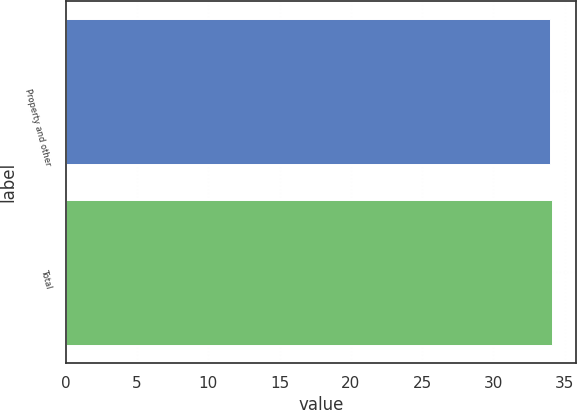Convert chart. <chart><loc_0><loc_0><loc_500><loc_500><bar_chart><fcel>Property and other<fcel>Total<nl><fcel>34<fcel>34.1<nl></chart> 